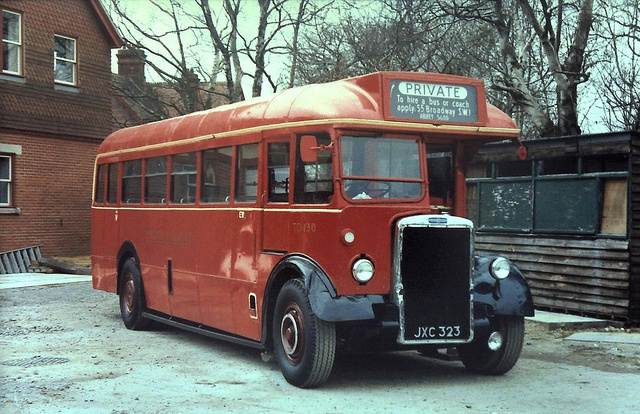Describe the objects in this image and their specific colors. I can see bus in black, brown, and gray tones in this image. 